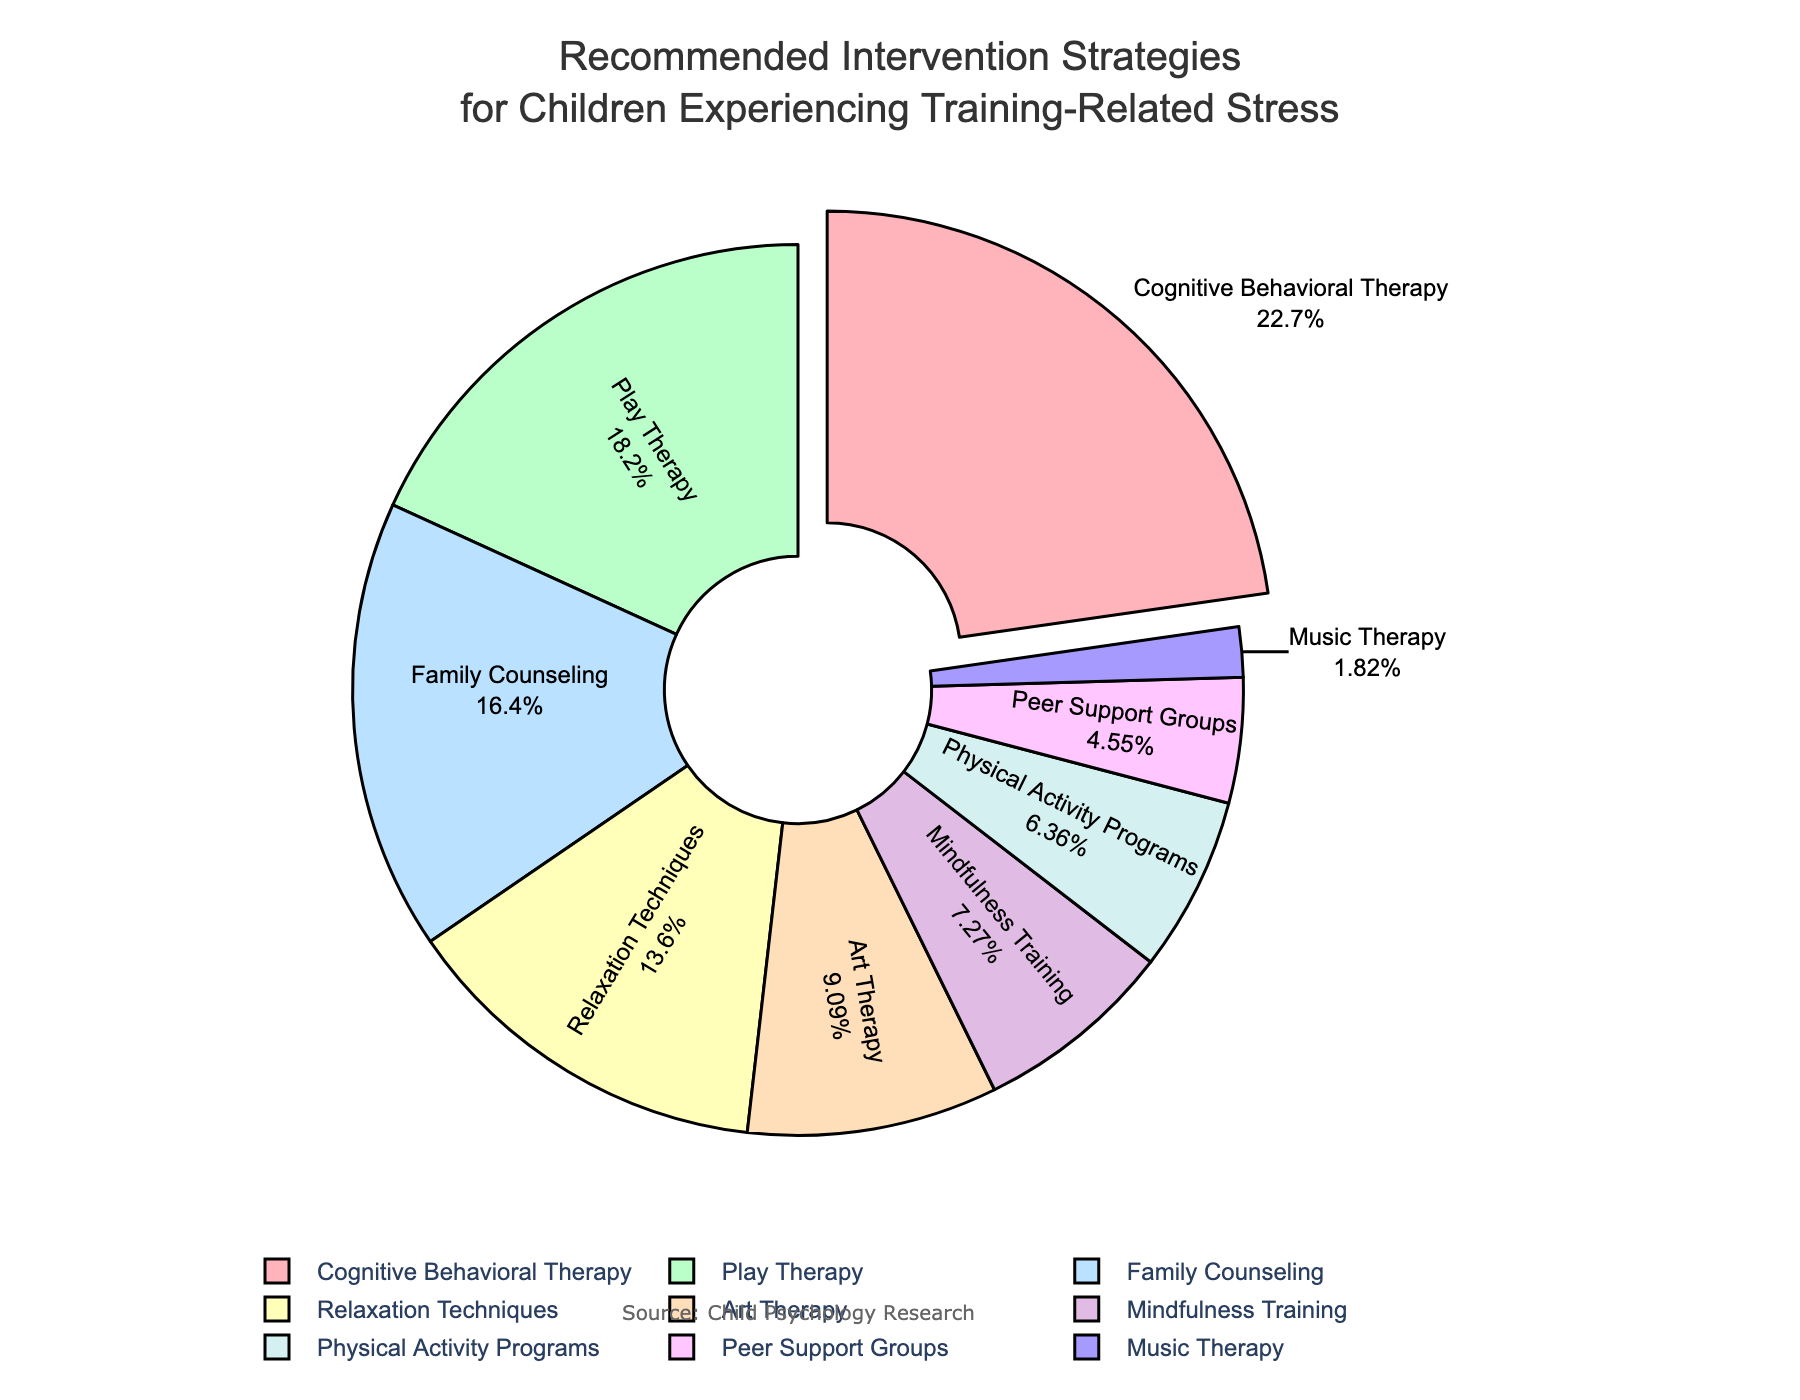what is the most recommended intervention strategy? The pie chart shows that Cognitive Behavioral Therapy has the largest percentage (25%). The slice is also slightly pulled out to highlight its prominence.
Answer: Cognitive Behavioral Therapy which strategies are recommended equally? By comparing the sizes of the slices, we can see that none of the intervention strategies have equal percentages in the pie chart.
Answer: None how much more recommended is Cognitive Behavioral Therapy compared to Music Therapy? Cognitive Behavioral Therapy has a recommendation percentage of 25%, while Music Therapy has 2%. Subtracting Music Therapy's percentage from Cognitive Behavioral Therapy's gives 25% - 2% = 23%.
Answer: 23% what is the combined percentage of Family Counseling and Physical Activity Programs? Family Counseling has a percentage of 18%, and Physical Activity Programs have 7%. Adding these together gives 18% + 7% = 25%.
Answer: 25% which strategy occupies the smallest portion of the chart? Observing the slices, Music Therapy, with 2%, occupies the smallest portion.
Answer: Music Therapy how many strategies are recommended at least 10% of the time? The slices with at least 10% are Cognitive Behavioral Therapy (25%), Play Therapy (20%), Family Counseling (18%), and Relaxation Techniques (15%), and Art Therapy (10%). Count of these strategies is 5.
Answer: 5 is the percentage of Play Therapy higher or lower than Relaxation Techniques? Comparing the two slices, Play Therapy (20%) is higher than Relaxation Techniques (15%).
Answer: Higher what is the difference in percentage between Family Counseling and Play Therapy? Family Counseling has a percentage of 18%, and Play Therapy has 20%. The difference is 20% - 18% = 2%.
Answer: 2% what is the total percentage represented by all the strategies combined? The percentages of all the strategies combined should sum to 100%.
Answer: 100% which strategy uses a blue-colored slice? From the color coding in the chart, Play Therapy is represented by the blue slice.
Answer: Play Therapy 